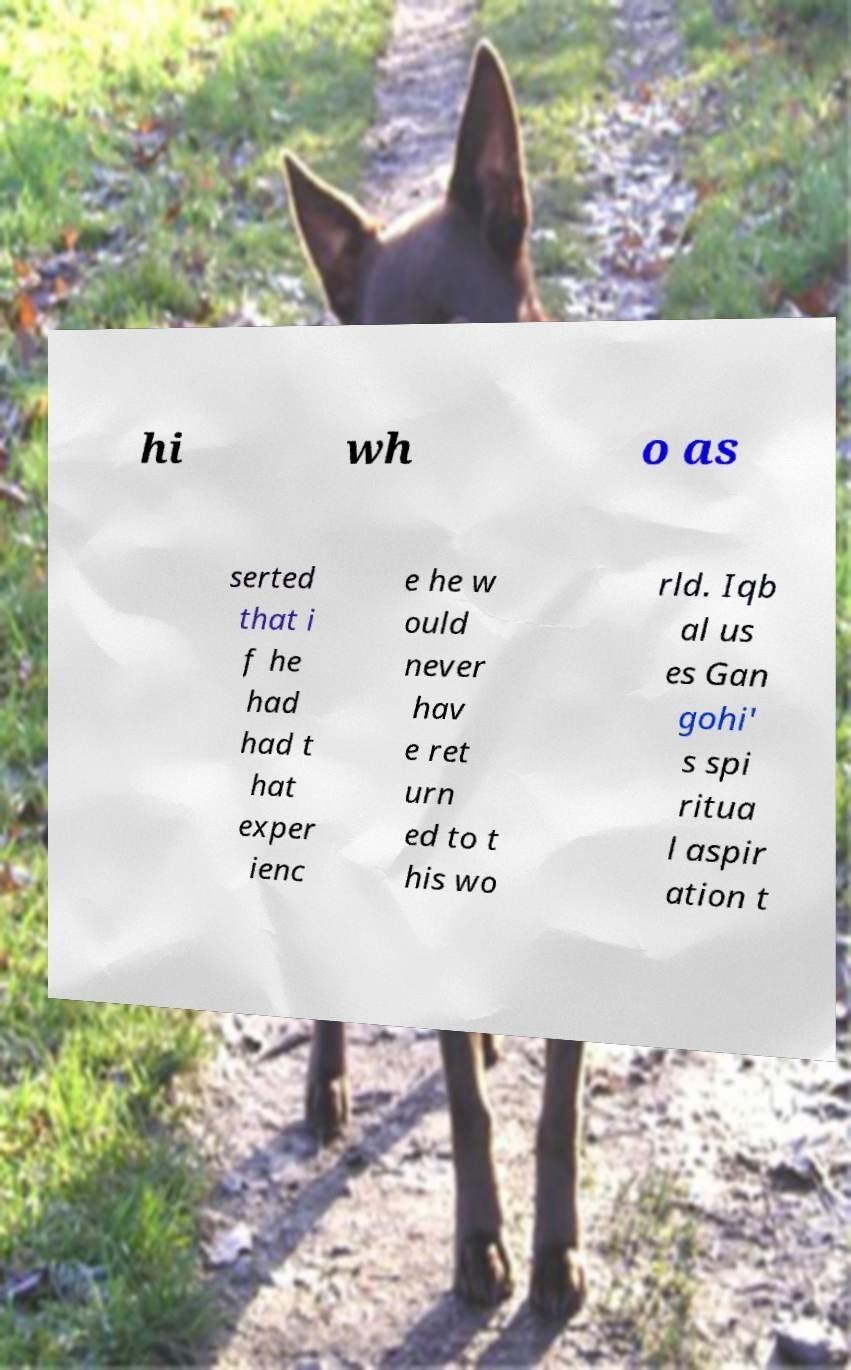Could you assist in decoding the text presented in this image and type it out clearly? hi wh o as serted that i f he had had t hat exper ienc e he w ould never hav e ret urn ed to t his wo rld. Iqb al us es Gan gohi' s spi ritua l aspir ation t 